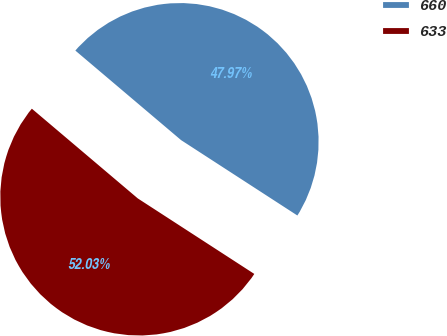<chart> <loc_0><loc_0><loc_500><loc_500><pie_chart><fcel>660<fcel>633<nl><fcel>47.97%<fcel>52.03%<nl></chart> 